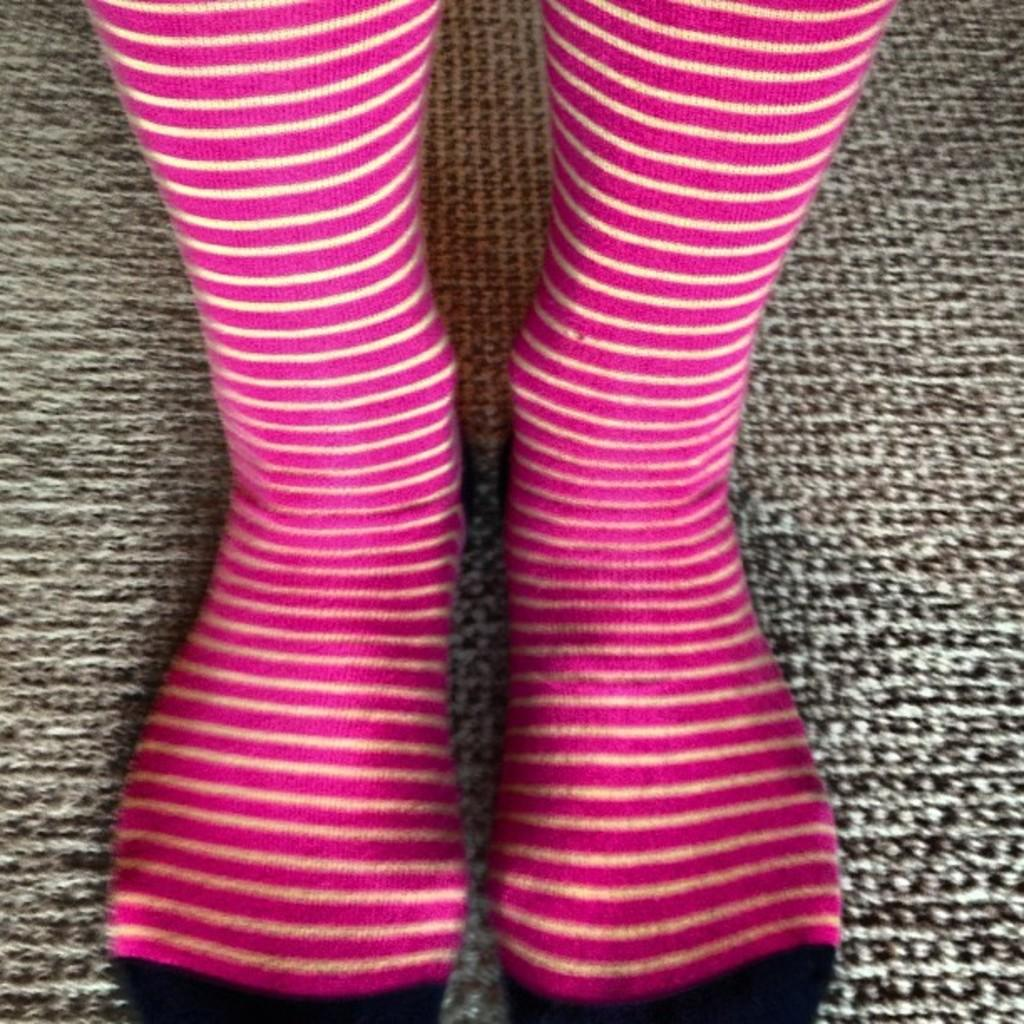What is present on the floor in the image? There is a mat on the floor in the image. What can be seen on the mat? There are legs visible on the mat. What are the legs wearing? The legs are wearing socks. Is there a woman operating a machine on the mat in the image? There is no woman or machine present on the mat in the image. 